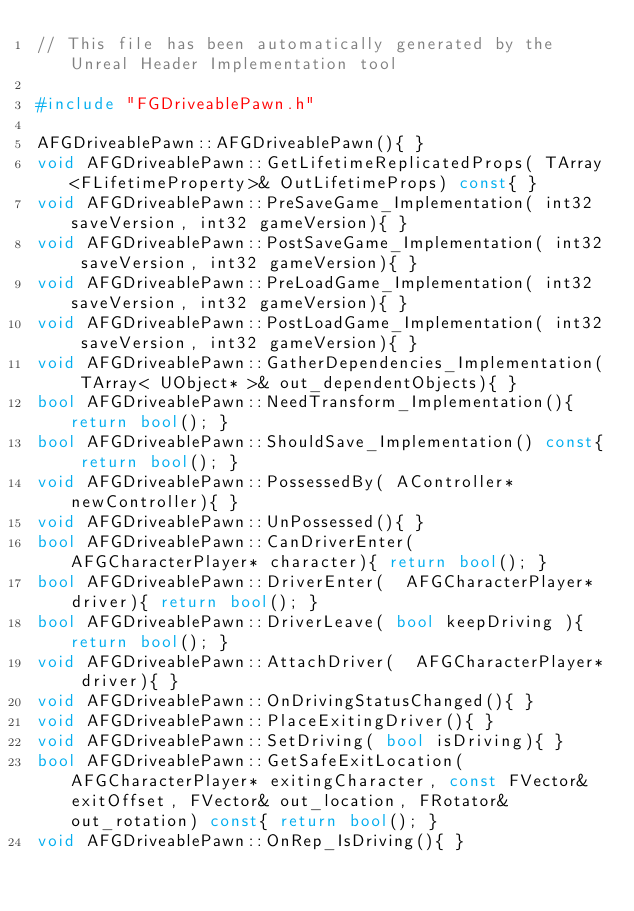<code> <loc_0><loc_0><loc_500><loc_500><_C++_>// This file has been automatically generated by the Unreal Header Implementation tool

#include "FGDriveablePawn.h"

AFGDriveablePawn::AFGDriveablePawn(){ }
void AFGDriveablePawn::GetLifetimeReplicatedProps( TArray<FLifetimeProperty>& OutLifetimeProps) const{ }
void AFGDriveablePawn::PreSaveGame_Implementation( int32 saveVersion, int32 gameVersion){ }
void AFGDriveablePawn::PostSaveGame_Implementation( int32 saveVersion, int32 gameVersion){ }
void AFGDriveablePawn::PreLoadGame_Implementation( int32 saveVersion, int32 gameVersion){ }
void AFGDriveablePawn::PostLoadGame_Implementation( int32 saveVersion, int32 gameVersion){ }
void AFGDriveablePawn::GatherDependencies_Implementation( TArray< UObject* >& out_dependentObjects){ }
bool AFGDriveablePawn::NeedTransform_Implementation(){ return bool(); }
bool AFGDriveablePawn::ShouldSave_Implementation() const{ return bool(); }
void AFGDriveablePawn::PossessedBy( AController* newController){ }
void AFGDriveablePawn::UnPossessed(){ }
bool AFGDriveablePawn::CanDriverEnter(  AFGCharacterPlayer* character){ return bool(); }
bool AFGDriveablePawn::DriverEnter(  AFGCharacterPlayer* driver){ return bool(); }
bool AFGDriveablePawn::DriverLeave( bool keepDriving ){ return bool(); }
void AFGDriveablePawn::AttachDriver(  AFGCharacterPlayer* driver){ }
void AFGDriveablePawn::OnDrivingStatusChanged(){ }
void AFGDriveablePawn::PlaceExitingDriver(){ }
void AFGDriveablePawn::SetDriving( bool isDriving){ }
bool AFGDriveablePawn::GetSafeExitLocation(  AFGCharacterPlayer* exitingCharacter, const FVector& exitOffset, FVector& out_location, FRotator& out_rotation) const{ return bool(); }
void AFGDriveablePawn::OnRep_IsDriving(){ }
</code> 